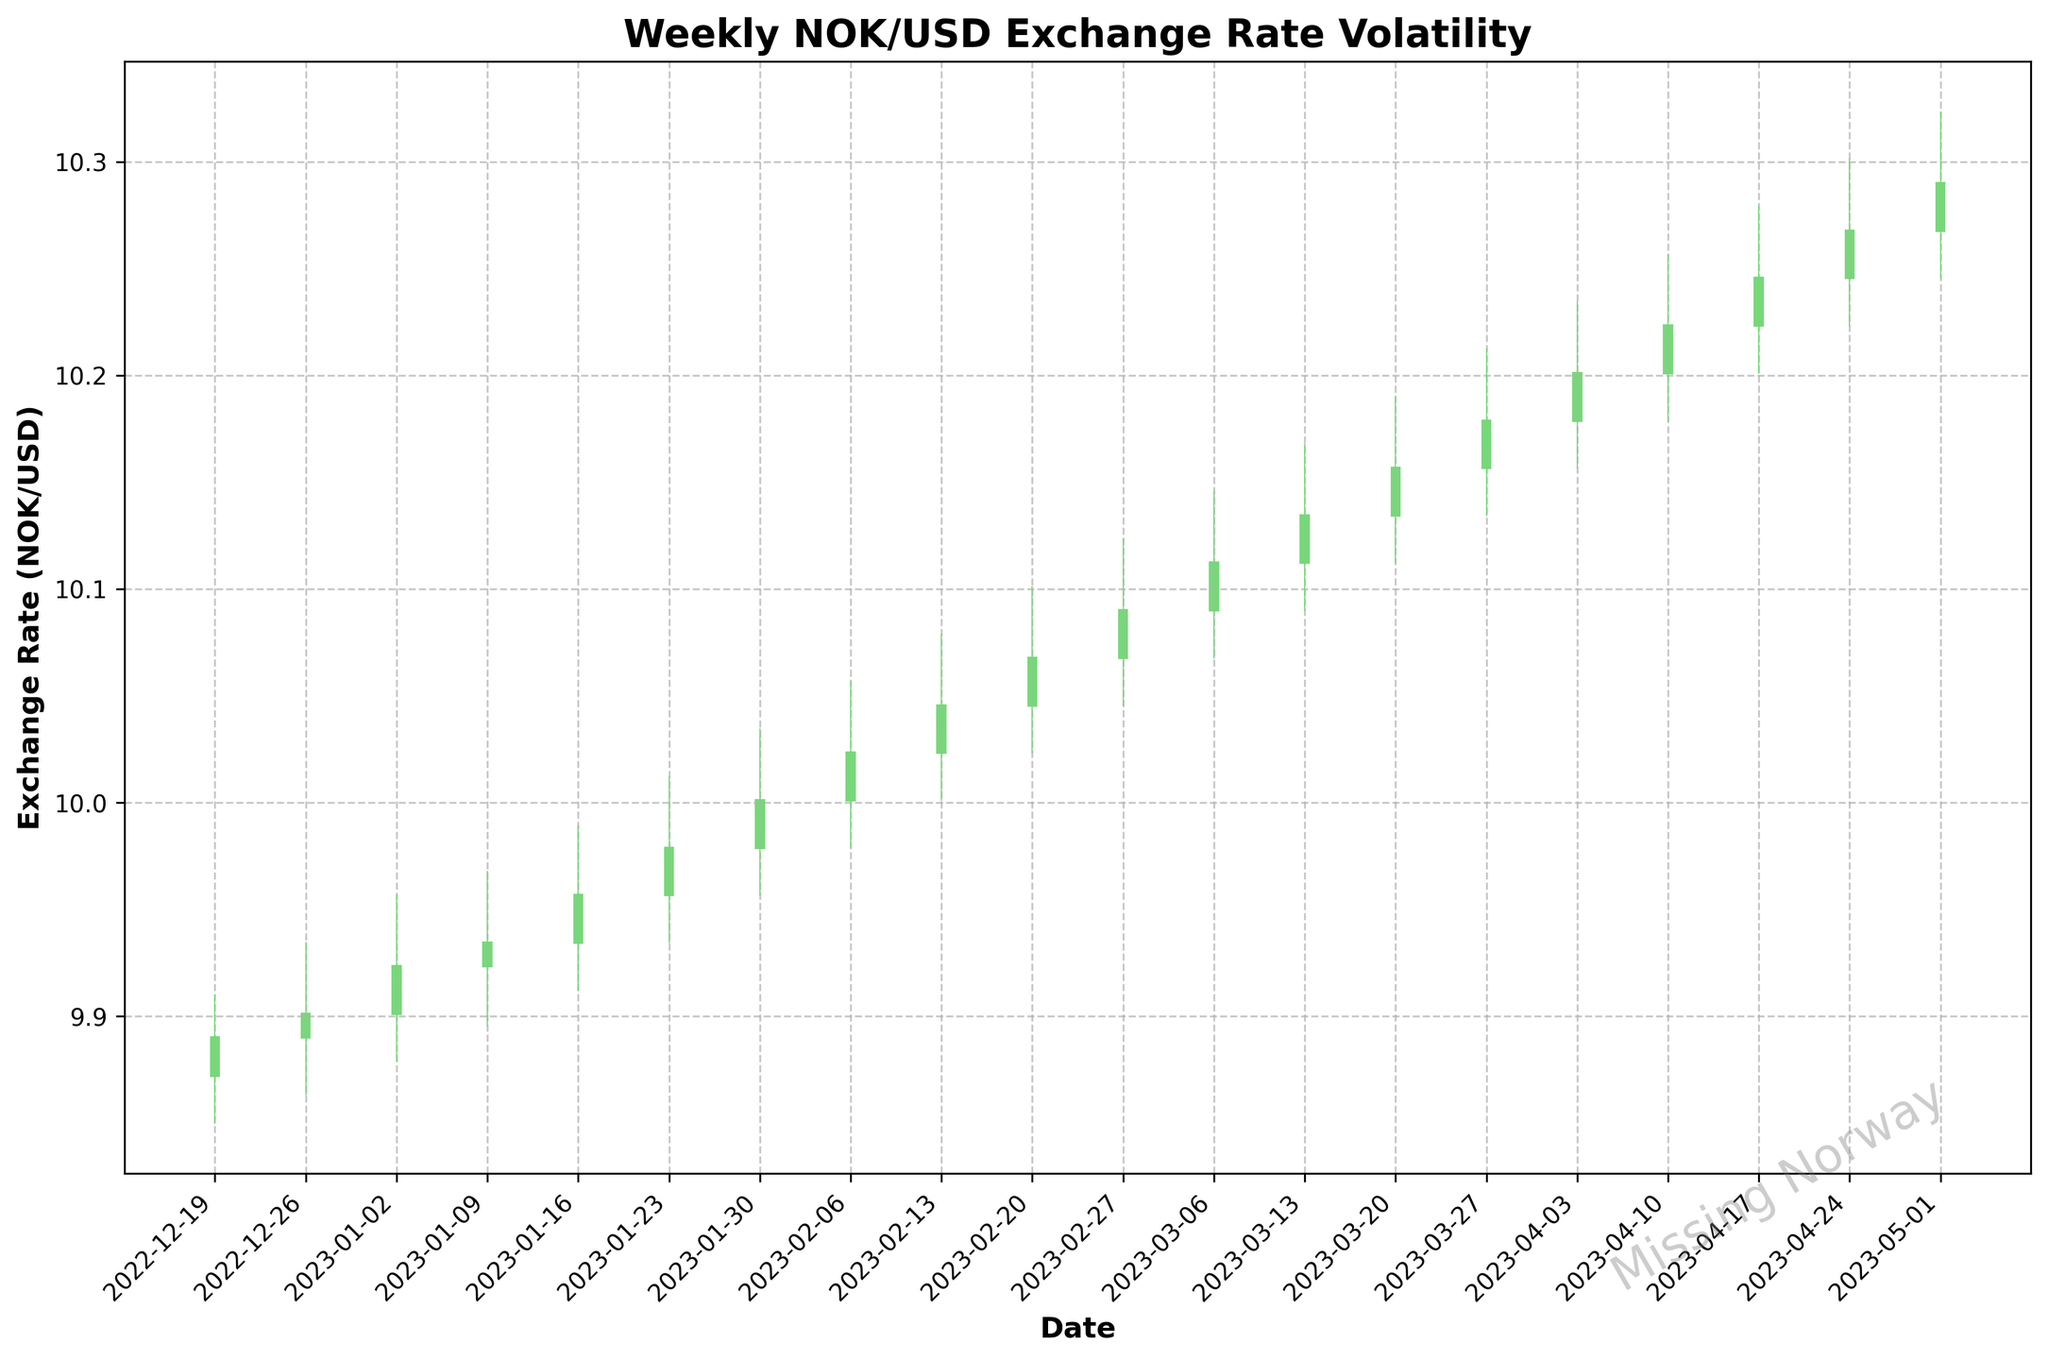When was the highest weekly closing rate for NOK/USD? To find the highest weekly closing rate, look at the "Close" column in the figure and pick the highest value, which is on the week of April 24, 2023, with a closing rate of 10.2901
Answer: April 24, 2023 Which week had the biggest weekly range (High minus Low)? Calculate the difference between the "High" and "Low" values for each week and find the week with the largest difference. The week of May 1, 2023, has the biggest range: 10.3234 - 10.2456 = 0.0778
Answer: May 1, 2023 What is the trend of the exchange rate from January to March 2023? Observe the weekly closing rates from January to March 2023. Starting from January 2 at 9.9234 and ending with March 27 at 10.1789, there is a general upward trend
Answer: Upward During which week did the exchange rate cross the 10 NOK/USD mark for the first time? Examine the closing rates sequentially until it exceeds 10. The week ending February 6, 2023, has a closing rate of 10.0012, which is the first time it surpasses 10 NOK/USD
Answer: February 6, 2023 Which week showed the smallest weekly change (absolute difference between Open and Close)? Calculate the absolute difference between the "Open" and "Close" for each week and find the smallest value. The week of February 20, 2023, has the smallest change:
Answer: February 20, 2023 Compare the opening and closing rates for the week of December 19, 2022. Was there an increase or decrease? Look at the "Open" and "Close" values for the week of December 19, 2022. The "Open" is 9.8723 and the "Close" is 9.8901. There is an increase
Answer: Increase How many weeks did the exchange rate stay above 10 NOK/USD? Count the weeks where the "Close" rate is greater than 10 NOK/USD. There are 12 weeks with closing rates above 10 NOK/USD
Answer: 12 weeks Calculate the average weekly closing rate for the first month of 2023. Sum the "Close" values for each week in January 2023 and divide by the number of weeks: (9.9234 + 9.9345 + 9.9567 + 9.9789) / 4 = 9.9484
Answer: 9.9484 Between the weeks of March 6 and March 20, 2023, did the exchange rate show more upward or downward movement? Compare the "Close" rates for the weeks between March 6 and March 20. The rates are increasing each week: 10.1123, 10.1345, and 10.1567 show an upward movement
Answer: Upward What is the highest value reached in the past year, and when did it occur? Locate the highest "High" value in the data and check the corresponding week. The highest value is 10.3234 during the week of May 1, 2023
Answer: 10.3234, May 1, 2023 